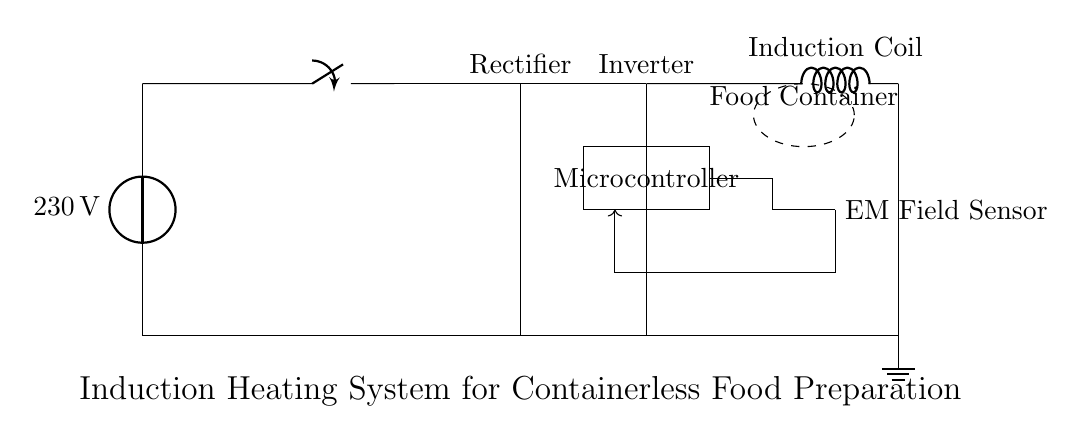What is the voltage of the power source in the circuit? The circuit diagram indicates that the power source is labeled as 230 volts, which shows the voltage supply to the system.
Answer: 230 volts What component converts AC to DC in the circuit? The circuit diagram shows a rectifier, which is the component specifically designed to convert alternating current (AC) from the power source into direct current (DC) for further processing.
Answer: Rectifier What role does the microcontroller play in this system? The microcontroller is placed in the circuit to manage the feedback from the electromagnetic field sensor and control the inverter operation, making it crucial for controlling the induction heating process.
Answer: Control How does the electromagnetic field sensor interact with the microcontroller? The sensor feeds data about the electromagnetic field to the microcontroller via a feedback loop represented by the arrow in the diagram, allowing the microcontroller to make adjustments based on the sensor's readings.
Answer: Feedback loop What type of coil is used in this induction heating system? In the circuit, the coil is specifically identified as an induction coil, which is a key component in generating the electromagnetic field necessary for heating.
Answer: Induction coil What does the dashed ellipse represent in the circuit diagram? The dashed ellipse labeled as "Food Container" indicates the area where the food is placed for heating, suggesting the system is designed for containerless preparation in microgravity environments.
Answer: Food Container Which component in the circuit is powered directly by the rectifier? The inverter follows the rectifier in the circuit and is directly powered by the DC output from it, expanding the functionality of the system to convert DC back to AC for the induction coil.
Answer: Inverter 